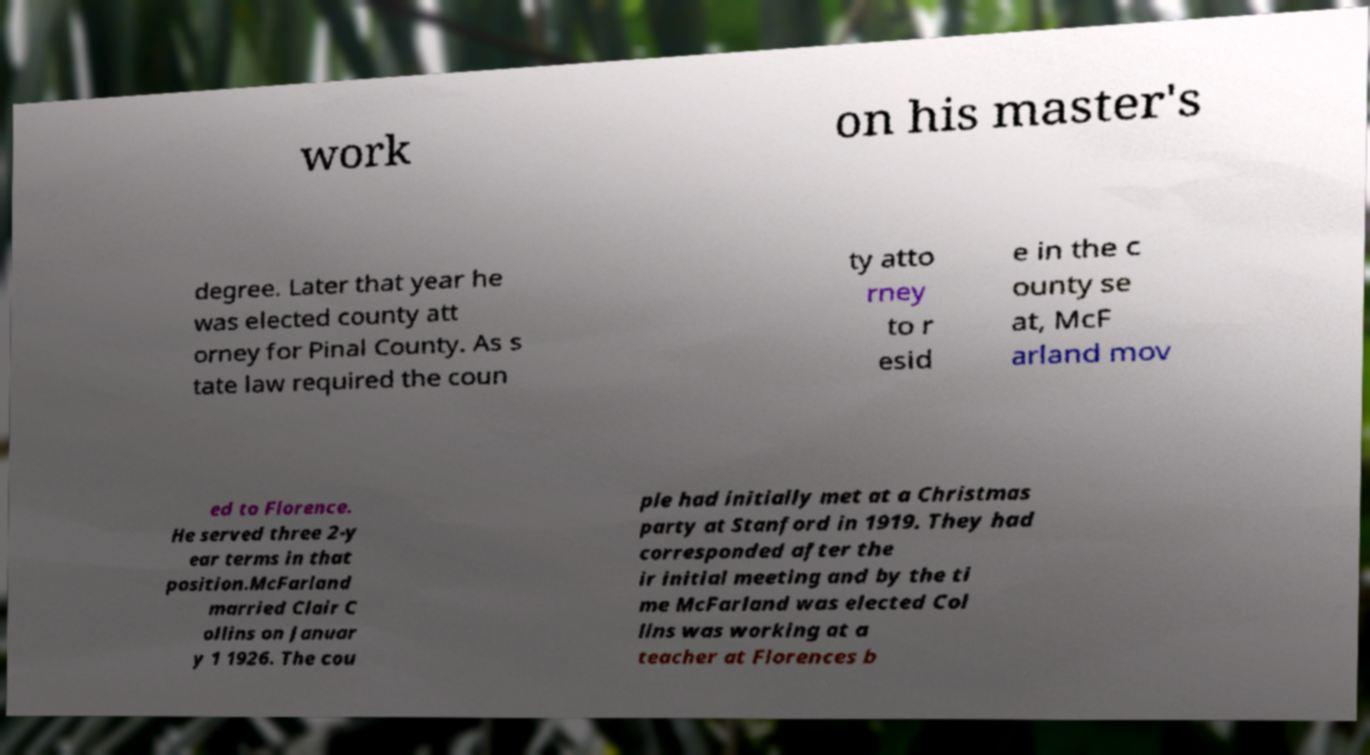Can you read and provide the text displayed in the image?This photo seems to have some interesting text. Can you extract and type it out for me? work on his master's degree. Later that year he was elected county att orney for Pinal County. As s tate law required the coun ty atto rney to r esid e in the c ounty se at, McF arland mov ed to Florence. He served three 2-y ear terms in that position.McFarland married Clair C ollins on Januar y 1 1926. The cou ple had initially met at a Christmas party at Stanford in 1919. They had corresponded after the ir initial meeting and by the ti me McFarland was elected Col lins was working at a teacher at Florences b 